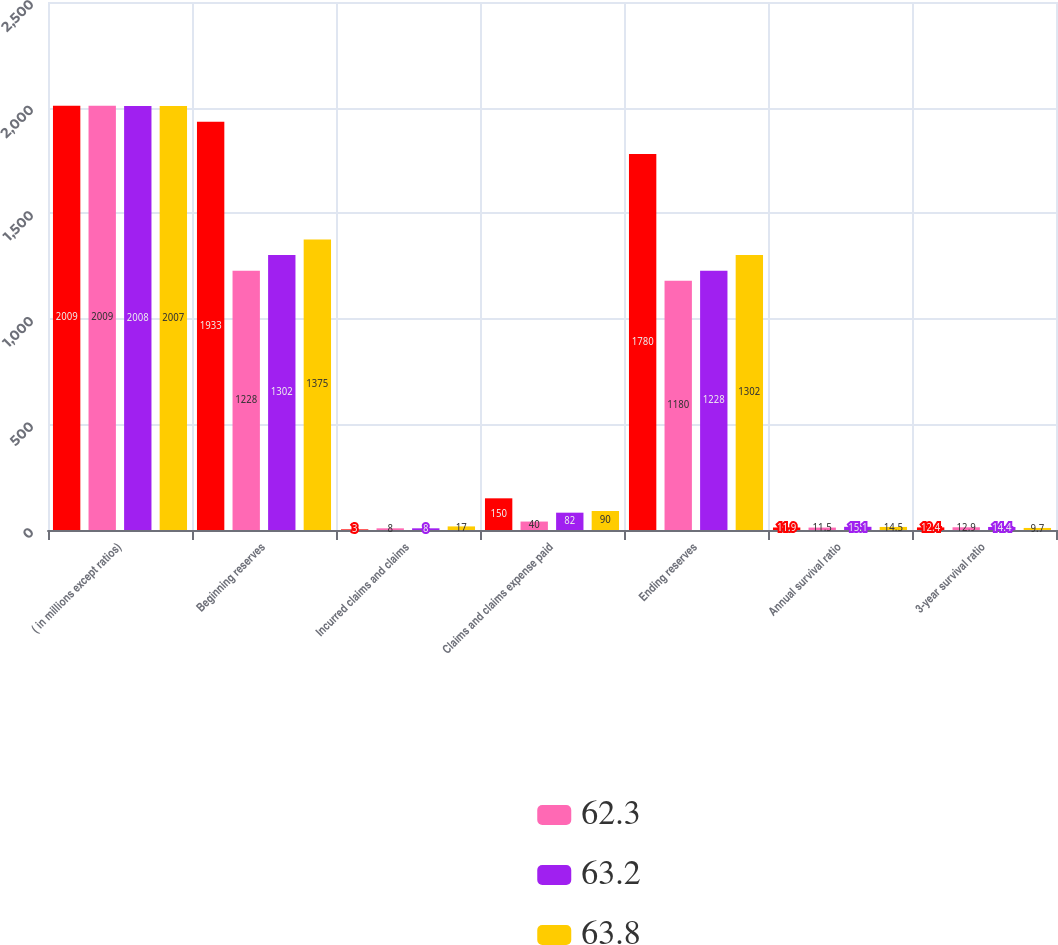Convert chart. <chart><loc_0><loc_0><loc_500><loc_500><stacked_bar_chart><ecel><fcel>( in millions except ratios)<fcel>Beginning reserves<fcel>Incurred claims and claims<fcel>Claims and claims expense paid<fcel>Ending reserves<fcel>Annual survival ratio<fcel>3-year survival ratio<nl><fcel>nan<fcel>2009<fcel>1933<fcel>3<fcel>150<fcel>1780<fcel>11.9<fcel>12.4<nl><fcel>62.3<fcel>2009<fcel>1228<fcel>8<fcel>40<fcel>1180<fcel>11.5<fcel>12.9<nl><fcel>63.2<fcel>2008<fcel>1302<fcel>8<fcel>82<fcel>1228<fcel>15.1<fcel>14.4<nl><fcel>63.8<fcel>2007<fcel>1375<fcel>17<fcel>90<fcel>1302<fcel>14.5<fcel>9.7<nl></chart> 